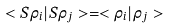Convert formula to latex. <formula><loc_0><loc_0><loc_500><loc_500>< S \rho _ { i } | S \rho _ { j } > = < \rho _ { i } | \rho _ { j } ></formula> 